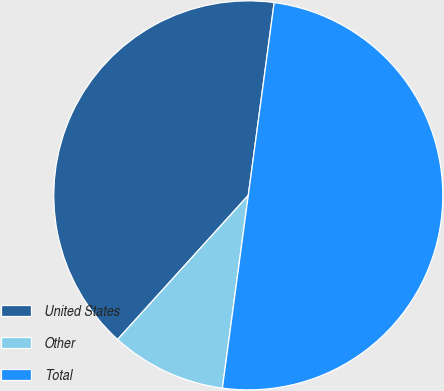Convert chart to OTSL. <chart><loc_0><loc_0><loc_500><loc_500><pie_chart><fcel>United States<fcel>Other<fcel>Total<nl><fcel>40.4%<fcel>9.6%<fcel>50.0%<nl></chart> 